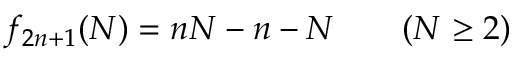<formula> <loc_0><loc_0><loc_500><loc_500>f _ { 2 n + 1 } ( N ) = n N - n - N \quad ( N \geq 2 )</formula> 